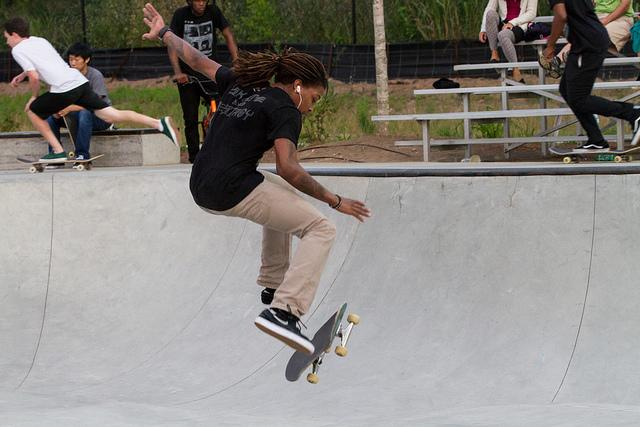What's the name of this type of skating area? Please explain your reasoning. bowl. This skating area is made of concrete with the most prominent feature that it has a big empty bottom.  this would most closely resemble a bowl. 